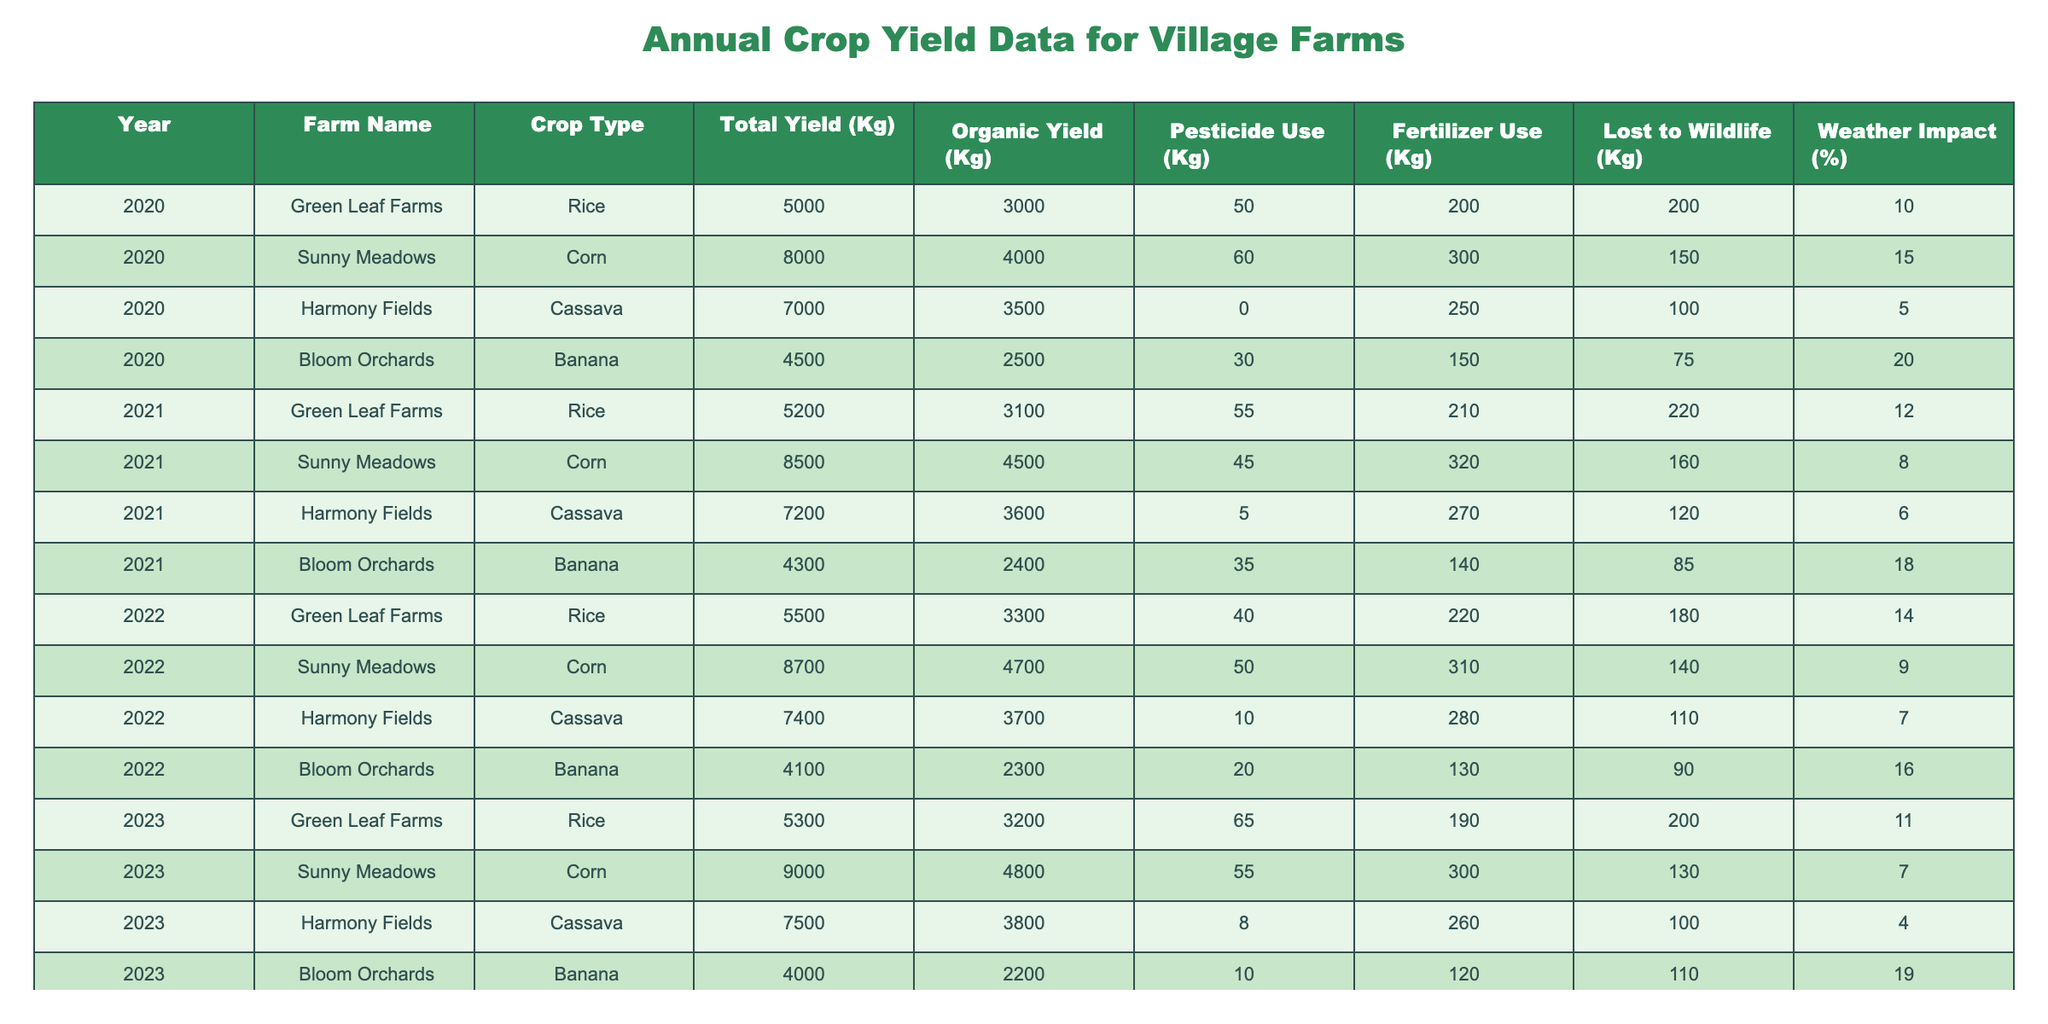What was the total yield of corn in 2022? In the table, the total yield for Sunny Meadows, which grows corn, is listed as 8700 Kg for the year 2022.
Answer: 8700 Kg Which farm had the highest organic yield in 2021? The organic yields for each farm in 2021 are: Green Leaf Farms - 3100 Kg, Sunny Meadows - 4500 Kg, Harmony Fields - 3600 Kg, Bloom Orchards - 2400 Kg. Sunny Meadows had the highest organic yield at 4500 Kg.
Answer: Sunny Meadows How much fertilizer was used for cassava in 2020? The table shows that Harmony Fields, which grows cassava, used 250 Kg of fertilizer in 2020.
Answer: 250 Kg What is the average total yield of rice across all years? The total yields for rice are: 5000 Kg (2020), 5200 Kg (2021), 5500 Kg (2022), and 5300 Kg (2023). The sum is 5000 + 5200 + 5500 + 5300 = 21000 Kg. Dividing by 4 gives an average of 5250 Kg.
Answer: 5250 Kg Did Harmony Fields use pesticides every year? The table lists pesticide use for Harmony Fields from 2020 to 2023. In 2020, they used 0 Kg, but in 2021, they used 5 Kg, 10 Kg in 2022, and 8 Kg in 2023. Therefore, they did not use pesticides every year.
Answer: No Which crop showed the least loss to wildlife in 2023? In 2023, the losses to wildlife are as follows: Rice - 200 Kg, Corn - 130 Kg, Cassava - 100 Kg, Banana - 110 Kg. Cassava had the least loss at 100 Kg.
Answer: Cassava What was the percentage impact of weather on yield for Banana in 2020? The table shows that the weather impact on yield for Banana in 2020 is 20%.
Answer: 20% Calculate the difference in total yield for Green Leaf Farms between 2020 and 2023. The total yield for Green Leaf Farms was 5000 Kg in 2020 and 5300 Kg in 2023. The difference is 5300 Kg - 5000 Kg = 300 Kg.
Answer: 300 Kg Which year had the lowest weather impact recorded? The weather impact percentages are: 10% (2020), 12% (2021), 14% (2022), and 11% (2023) for rice, corn, cassava, and bananas respectively. The lowest recorded was 4% for Cassava in 2023.
Answer: 4% in 2023 In what year did Sunny Meadows have the highest total yield for corn? By examining the table, Sunny Meadows had total yields of 8000 Kg (2020), 8500 Kg (2021), 8700 Kg (2022), and 9000 Kg (2023). The highest total yield was in 2023 at 9000 Kg.
Answer: 2023 